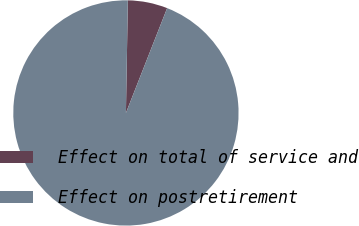<chart> <loc_0><loc_0><loc_500><loc_500><pie_chart><fcel>Effect on total of service and<fcel>Effect on postretirement<nl><fcel>5.69%<fcel>94.31%<nl></chart> 